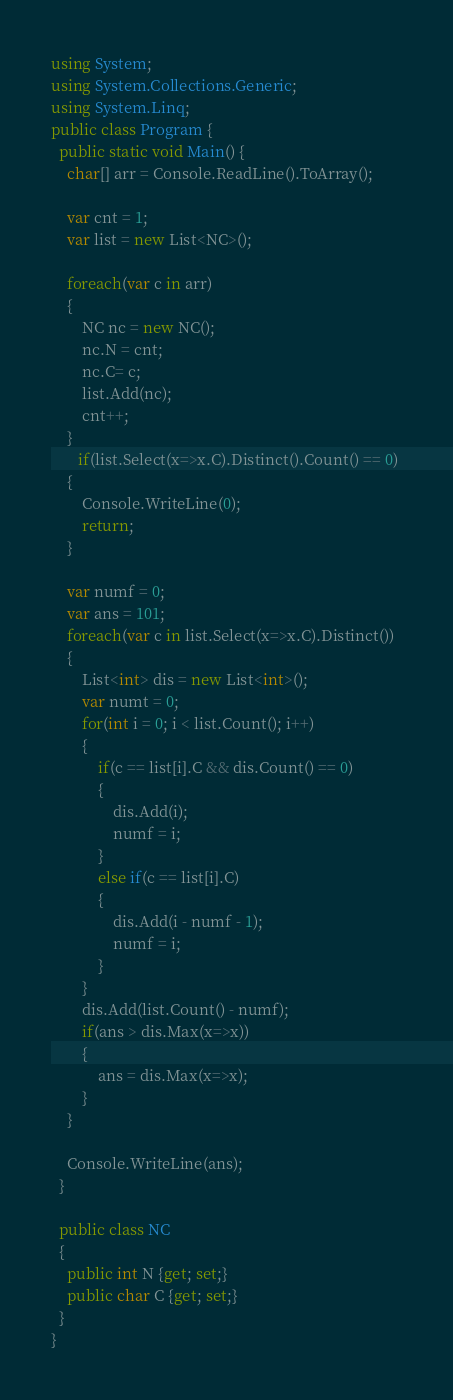Convert code to text. <code><loc_0><loc_0><loc_500><loc_500><_C#_>using System;
using System.Collections.Generic;
using System.Linq;
public class Program {
  public static void Main() {
  	char[] arr = Console.ReadLine().ToArray();
	
	var cnt = 1;	
	var list = new List<NC>();
	
	foreach(var c in arr)
	{
		NC nc = new NC();
		nc.N = cnt;
		nc.C= c;
		list.Add(nc);
		cnt++;
	}
       if(list.Select(x=>x.C).Distinct().Count() == 0) 
	{
		Console.WriteLine(0);
		return;
	}

	var numf = 0;
	var ans = 101;
	foreach(var c in list.Select(x=>x.C).Distinct())
	{
		List<int> dis = new List<int>();
		var numt = 0;
		for(int i = 0; i < list.Count(); i++)
		{	
			if(c == list[i].C && dis.Count() == 0)
			{
				dis.Add(i);
				numf = i;
			}
			else if(c == list[i].C)
			{
				dis.Add(i - numf - 1);
				numf = i;
			}			
		}
		dis.Add(list.Count() - numf);
		if(ans > dis.Max(x=>x))
		{
			ans = dis.Max(x=>x);
		}
	}
	
	Console.WriteLine(ans);
  }
  
  public class NC 
  {
  	public int N {get; set;}
  	public char C {get; set;}
  }
}</code> 